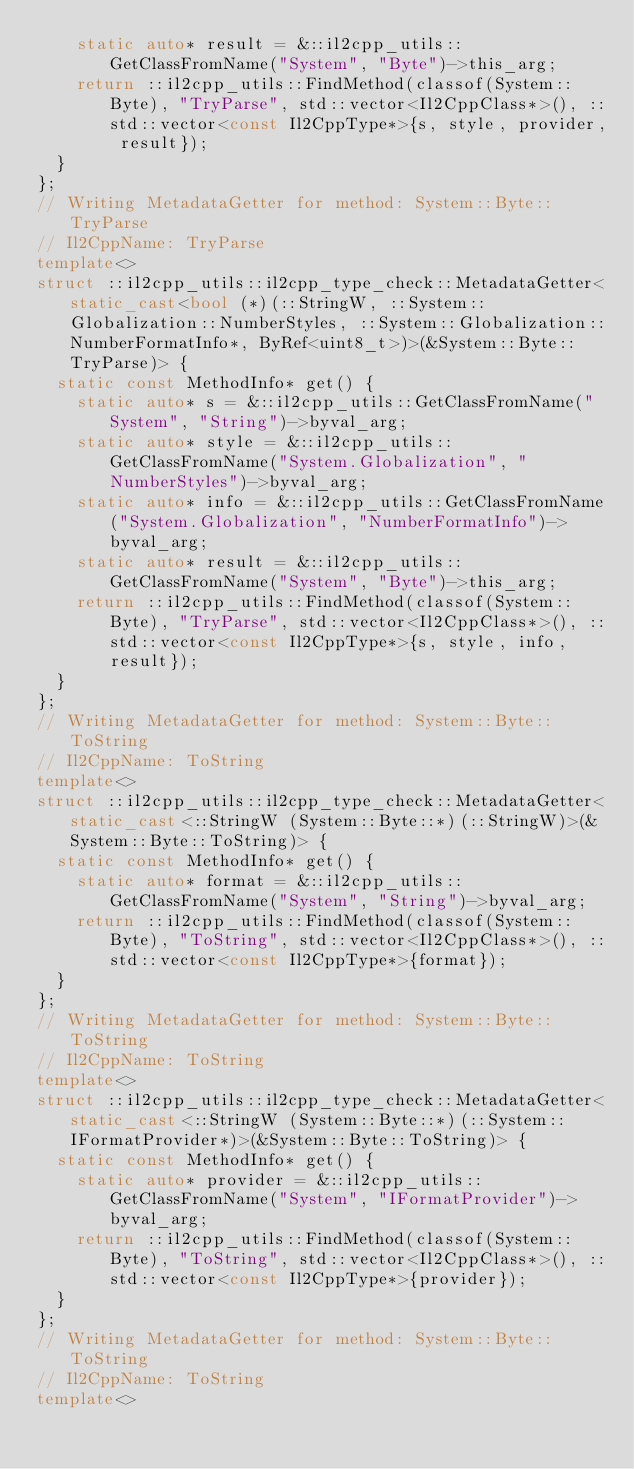Convert code to text. <code><loc_0><loc_0><loc_500><loc_500><_C++_>    static auto* result = &::il2cpp_utils::GetClassFromName("System", "Byte")->this_arg;
    return ::il2cpp_utils::FindMethod(classof(System::Byte), "TryParse", std::vector<Il2CppClass*>(), ::std::vector<const Il2CppType*>{s, style, provider, result});
  }
};
// Writing MetadataGetter for method: System::Byte::TryParse
// Il2CppName: TryParse
template<>
struct ::il2cpp_utils::il2cpp_type_check::MetadataGetter<static_cast<bool (*)(::StringW, ::System::Globalization::NumberStyles, ::System::Globalization::NumberFormatInfo*, ByRef<uint8_t>)>(&System::Byte::TryParse)> {
  static const MethodInfo* get() {
    static auto* s = &::il2cpp_utils::GetClassFromName("System", "String")->byval_arg;
    static auto* style = &::il2cpp_utils::GetClassFromName("System.Globalization", "NumberStyles")->byval_arg;
    static auto* info = &::il2cpp_utils::GetClassFromName("System.Globalization", "NumberFormatInfo")->byval_arg;
    static auto* result = &::il2cpp_utils::GetClassFromName("System", "Byte")->this_arg;
    return ::il2cpp_utils::FindMethod(classof(System::Byte), "TryParse", std::vector<Il2CppClass*>(), ::std::vector<const Il2CppType*>{s, style, info, result});
  }
};
// Writing MetadataGetter for method: System::Byte::ToString
// Il2CppName: ToString
template<>
struct ::il2cpp_utils::il2cpp_type_check::MetadataGetter<static_cast<::StringW (System::Byte::*)(::StringW)>(&System::Byte::ToString)> {
  static const MethodInfo* get() {
    static auto* format = &::il2cpp_utils::GetClassFromName("System", "String")->byval_arg;
    return ::il2cpp_utils::FindMethod(classof(System::Byte), "ToString", std::vector<Il2CppClass*>(), ::std::vector<const Il2CppType*>{format});
  }
};
// Writing MetadataGetter for method: System::Byte::ToString
// Il2CppName: ToString
template<>
struct ::il2cpp_utils::il2cpp_type_check::MetadataGetter<static_cast<::StringW (System::Byte::*)(::System::IFormatProvider*)>(&System::Byte::ToString)> {
  static const MethodInfo* get() {
    static auto* provider = &::il2cpp_utils::GetClassFromName("System", "IFormatProvider")->byval_arg;
    return ::il2cpp_utils::FindMethod(classof(System::Byte), "ToString", std::vector<Il2CppClass*>(), ::std::vector<const Il2CppType*>{provider});
  }
};
// Writing MetadataGetter for method: System::Byte::ToString
// Il2CppName: ToString
template<></code> 